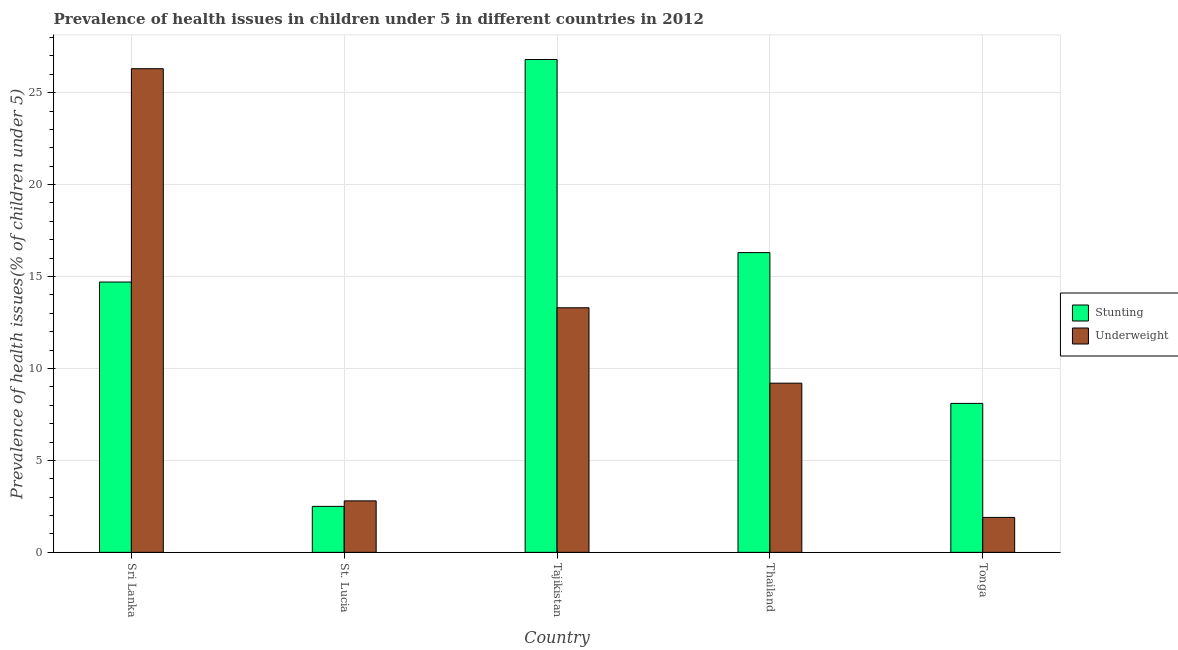Are the number of bars per tick equal to the number of legend labels?
Make the answer very short. Yes. Are the number of bars on each tick of the X-axis equal?
Ensure brevity in your answer.  Yes. How many bars are there on the 2nd tick from the right?
Offer a very short reply. 2. What is the label of the 5th group of bars from the left?
Your answer should be very brief. Tonga. In how many cases, is the number of bars for a given country not equal to the number of legend labels?
Provide a succinct answer. 0. What is the percentage of stunted children in Sri Lanka?
Give a very brief answer. 14.7. Across all countries, what is the maximum percentage of underweight children?
Give a very brief answer. 26.3. Across all countries, what is the minimum percentage of underweight children?
Your answer should be compact. 1.9. In which country was the percentage of stunted children maximum?
Make the answer very short. Tajikistan. In which country was the percentage of stunted children minimum?
Offer a terse response. St. Lucia. What is the total percentage of stunted children in the graph?
Your response must be concise. 68.4. What is the difference between the percentage of underweight children in St. Lucia and that in Tajikistan?
Ensure brevity in your answer.  -10.5. What is the difference between the percentage of underweight children in Tonga and the percentage of stunted children in St. Lucia?
Make the answer very short. -0.6. What is the average percentage of stunted children per country?
Your answer should be very brief. 13.68. What is the difference between the percentage of underweight children and percentage of stunted children in Sri Lanka?
Offer a terse response. 11.6. In how many countries, is the percentage of stunted children greater than 14 %?
Give a very brief answer. 3. What is the ratio of the percentage of stunted children in Sri Lanka to that in St. Lucia?
Your response must be concise. 5.88. Is the difference between the percentage of underweight children in St. Lucia and Thailand greater than the difference between the percentage of stunted children in St. Lucia and Thailand?
Offer a terse response. Yes. What is the difference between the highest and the second highest percentage of stunted children?
Your answer should be very brief. 10.5. What is the difference between the highest and the lowest percentage of underweight children?
Your answer should be compact. 24.4. What does the 2nd bar from the left in Tajikistan represents?
Ensure brevity in your answer.  Underweight. What does the 2nd bar from the right in Tonga represents?
Offer a terse response. Stunting. How many bars are there?
Make the answer very short. 10. Are all the bars in the graph horizontal?
Your answer should be compact. No. Are the values on the major ticks of Y-axis written in scientific E-notation?
Your answer should be very brief. No. Does the graph contain any zero values?
Offer a terse response. No. Where does the legend appear in the graph?
Make the answer very short. Center right. How many legend labels are there?
Give a very brief answer. 2. What is the title of the graph?
Your response must be concise. Prevalence of health issues in children under 5 in different countries in 2012. What is the label or title of the Y-axis?
Offer a terse response. Prevalence of health issues(% of children under 5). What is the Prevalence of health issues(% of children under 5) in Stunting in Sri Lanka?
Your answer should be very brief. 14.7. What is the Prevalence of health issues(% of children under 5) of Underweight in Sri Lanka?
Your answer should be compact. 26.3. What is the Prevalence of health issues(% of children under 5) of Stunting in St. Lucia?
Ensure brevity in your answer.  2.5. What is the Prevalence of health issues(% of children under 5) of Underweight in St. Lucia?
Provide a short and direct response. 2.8. What is the Prevalence of health issues(% of children under 5) of Stunting in Tajikistan?
Offer a very short reply. 26.8. What is the Prevalence of health issues(% of children under 5) of Underweight in Tajikistan?
Offer a very short reply. 13.3. What is the Prevalence of health issues(% of children under 5) of Stunting in Thailand?
Offer a very short reply. 16.3. What is the Prevalence of health issues(% of children under 5) in Underweight in Thailand?
Give a very brief answer. 9.2. What is the Prevalence of health issues(% of children under 5) of Stunting in Tonga?
Keep it short and to the point. 8.1. What is the Prevalence of health issues(% of children under 5) in Underweight in Tonga?
Keep it short and to the point. 1.9. Across all countries, what is the maximum Prevalence of health issues(% of children under 5) of Stunting?
Offer a very short reply. 26.8. Across all countries, what is the maximum Prevalence of health issues(% of children under 5) of Underweight?
Keep it short and to the point. 26.3. Across all countries, what is the minimum Prevalence of health issues(% of children under 5) in Underweight?
Offer a terse response. 1.9. What is the total Prevalence of health issues(% of children under 5) of Stunting in the graph?
Ensure brevity in your answer.  68.4. What is the total Prevalence of health issues(% of children under 5) in Underweight in the graph?
Offer a very short reply. 53.5. What is the difference between the Prevalence of health issues(% of children under 5) of Stunting in Sri Lanka and that in St. Lucia?
Give a very brief answer. 12.2. What is the difference between the Prevalence of health issues(% of children under 5) of Underweight in Sri Lanka and that in St. Lucia?
Make the answer very short. 23.5. What is the difference between the Prevalence of health issues(% of children under 5) in Underweight in Sri Lanka and that in Tajikistan?
Provide a short and direct response. 13. What is the difference between the Prevalence of health issues(% of children under 5) in Stunting in Sri Lanka and that in Thailand?
Offer a terse response. -1.6. What is the difference between the Prevalence of health issues(% of children under 5) in Underweight in Sri Lanka and that in Tonga?
Offer a very short reply. 24.4. What is the difference between the Prevalence of health issues(% of children under 5) of Stunting in St. Lucia and that in Tajikistan?
Make the answer very short. -24.3. What is the difference between the Prevalence of health issues(% of children under 5) of Underweight in St. Lucia and that in Tajikistan?
Your answer should be very brief. -10.5. What is the difference between the Prevalence of health issues(% of children under 5) in Stunting in St. Lucia and that in Thailand?
Keep it short and to the point. -13.8. What is the difference between the Prevalence of health issues(% of children under 5) of Underweight in St. Lucia and that in Thailand?
Give a very brief answer. -6.4. What is the difference between the Prevalence of health issues(% of children under 5) of Underweight in St. Lucia and that in Tonga?
Your answer should be very brief. 0.9. What is the difference between the Prevalence of health issues(% of children under 5) in Underweight in Tajikistan and that in Thailand?
Your response must be concise. 4.1. What is the difference between the Prevalence of health issues(% of children under 5) in Stunting in Tajikistan and that in Tonga?
Your answer should be compact. 18.7. What is the difference between the Prevalence of health issues(% of children under 5) of Underweight in Tajikistan and that in Tonga?
Offer a very short reply. 11.4. What is the difference between the Prevalence of health issues(% of children under 5) of Stunting in Thailand and that in Tonga?
Keep it short and to the point. 8.2. What is the difference between the Prevalence of health issues(% of children under 5) of Stunting in Sri Lanka and the Prevalence of health issues(% of children under 5) of Underweight in Tajikistan?
Your answer should be compact. 1.4. What is the difference between the Prevalence of health issues(% of children under 5) of Stunting in Sri Lanka and the Prevalence of health issues(% of children under 5) of Underweight in Thailand?
Offer a terse response. 5.5. What is the difference between the Prevalence of health issues(% of children under 5) of Stunting in St. Lucia and the Prevalence of health issues(% of children under 5) of Underweight in Thailand?
Your answer should be compact. -6.7. What is the difference between the Prevalence of health issues(% of children under 5) of Stunting in Tajikistan and the Prevalence of health issues(% of children under 5) of Underweight in Thailand?
Provide a short and direct response. 17.6. What is the difference between the Prevalence of health issues(% of children under 5) in Stunting in Tajikistan and the Prevalence of health issues(% of children under 5) in Underweight in Tonga?
Ensure brevity in your answer.  24.9. What is the difference between the Prevalence of health issues(% of children under 5) of Stunting in Thailand and the Prevalence of health issues(% of children under 5) of Underweight in Tonga?
Your response must be concise. 14.4. What is the average Prevalence of health issues(% of children under 5) in Stunting per country?
Your answer should be very brief. 13.68. What is the difference between the Prevalence of health issues(% of children under 5) in Stunting and Prevalence of health issues(% of children under 5) in Underweight in Sri Lanka?
Keep it short and to the point. -11.6. What is the difference between the Prevalence of health issues(% of children under 5) in Stunting and Prevalence of health issues(% of children under 5) in Underweight in St. Lucia?
Your answer should be very brief. -0.3. What is the ratio of the Prevalence of health issues(% of children under 5) in Stunting in Sri Lanka to that in St. Lucia?
Give a very brief answer. 5.88. What is the ratio of the Prevalence of health issues(% of children under 5) of Underweight in Sri Lanka to that in St. Lucia?
Provide a succinct answer. 9.39. What is the ratio of the Prevalence of health issues(% of children under 5) of Stunting in Sri Lanka to that in Tajikistan?
Provide a succinct answer. 0.55. What is the ratio of the Prevalence of health issues(% of children under 5) in Underweight in Sri Lanka to that in Tajikistan?
Offer a very short reply. 1.98. What is the ratio of the Prevalence of health issues(% of children under 5) of Stunting in Sri Lanka to that in Thailand?
Give a very brief answer. 0.9. What is the ratio of the Prevalence of health issues(% of children under 5) in Underweight in Sri Lanka to that in Thailand?
Ensure brevity in your answer.  2.86. What is the ratio of the Prevalence of health issues(% of children under 5) in Stunting in Sri Lanka to that in Tonga?
Your response must be concise. 1.81. What is the ratio of the Prevalence of health issues(% of children under 5) in Underweight in Sri Lanka to that in Tonga?
Provide a short and direct response. 13.84. What is the ratio of the Prevalence of health issues(% of children under 5) of Stunting in St. Lucia to that in Tajikistan?
Keep it short and to the point. 0.09. What is the ratio of the Prevalence of health issues(% of children under 5) in Underweight in St. Lucia to that in Tajikistan?
Your response must be concise. 0.21. What is the ratio of the Prevalence of health issues(% of children under 5) of Stunting in St. Lucia to that in Thailand?
Keep it short and to the point. 0.15. What is the ratio of the Prevalence of health issues(% of children under 5) in Underweight in St. Lucia to that in Thailand?
Offer a very short reply. 0.3. What is the ratio of the Prevalence of health issues(% of children under 5) of Stunting in St. Lucia to that in Tonga?
Your response must be concise. 0.31. What is the ratio of the Prevalence of health issues(% of children under 5) in Underweight in St. Lucia to that in Tonga?
Your response must be concise. 1.47. What is the ratio of the Prevalence of health issues(% of children under 5) of Stunting in Tajikistan to that in Thailand?
Offer a very short reply. 1.64. What is the ratio of the Prevalence of health issues(% of children under 5) of Underweight in Tajikistan to that in Thailand?
Offer a terse response. 1.45. What is the ratio of the Prevalence of health issues(% of children under 5) of Stunting in Tajikistan to that in Tonga?
Offer a very short reply. 3.31. What is the ratio of the Prevalence of health issues(% of children under 5) in Stunting in Thailand to that in Tonga?
Offer a terse response. 2.01. What is the ratio of the Prevalence of health issues(% of children under 5) in Underweight in Thailand to that in Tonga?
Your response must be concise. 4.84. What is the difference between the highest and the lowest Prevalence of health issues(% of children under 5) in Stunting?
Make the answer very short. 24.3. What is the difference between the highest and the lowest Prevalence of health issues(% of children under 5) of Underweight?
Offer a terse response. 24.4. 